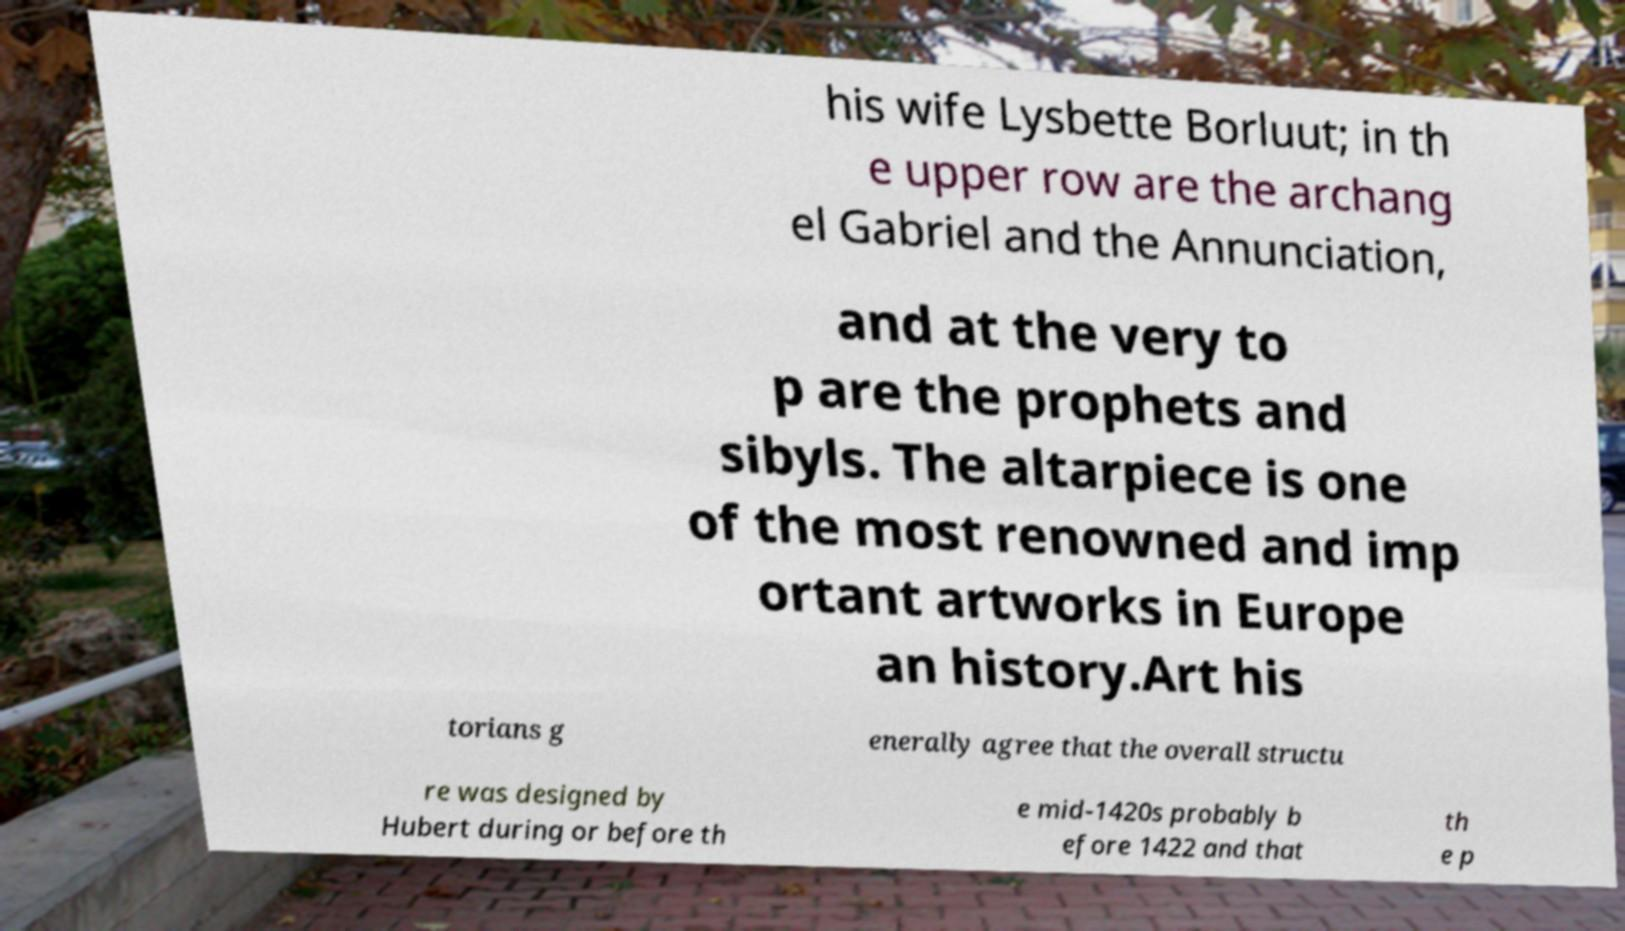Please read and relay the text visible in this image. What does it say? his wife Lysbette Borluut; in th e upper row are the archang el Gabriel and the Annunciation, and at the very to p are the prophets and sibyls. The altarpiece is one of the most renowned and imp ortant artworks in Europe an history.Art his torians g enerally agree that the overall structu re was designed by Hubert during or before th e mid-1420s probably b efore 1422 and that th e p 